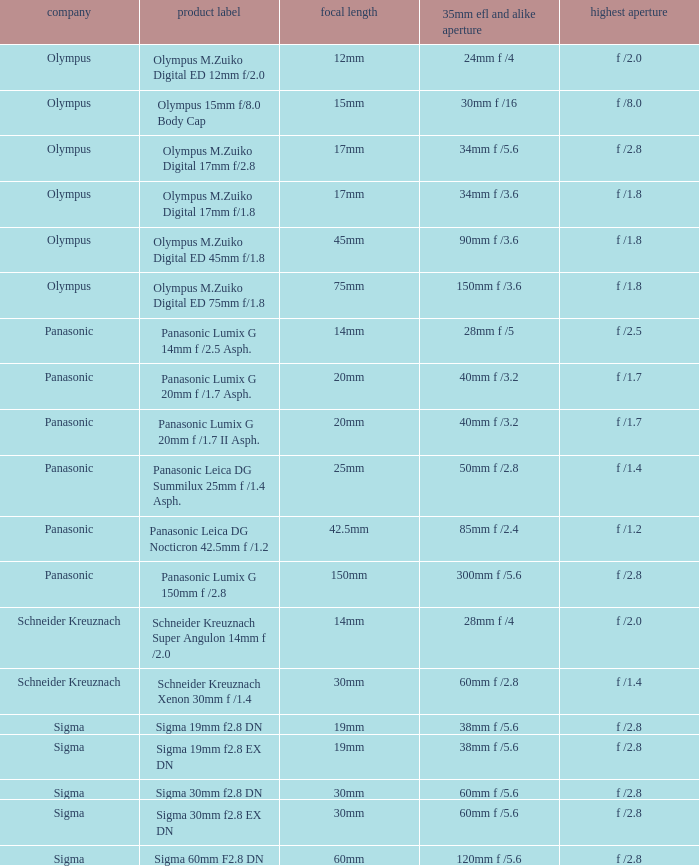What is the 35mm EFL and the equivalent aperture of the lens(es) with a maximum aperture of f /2.5? 28mm f /5. 